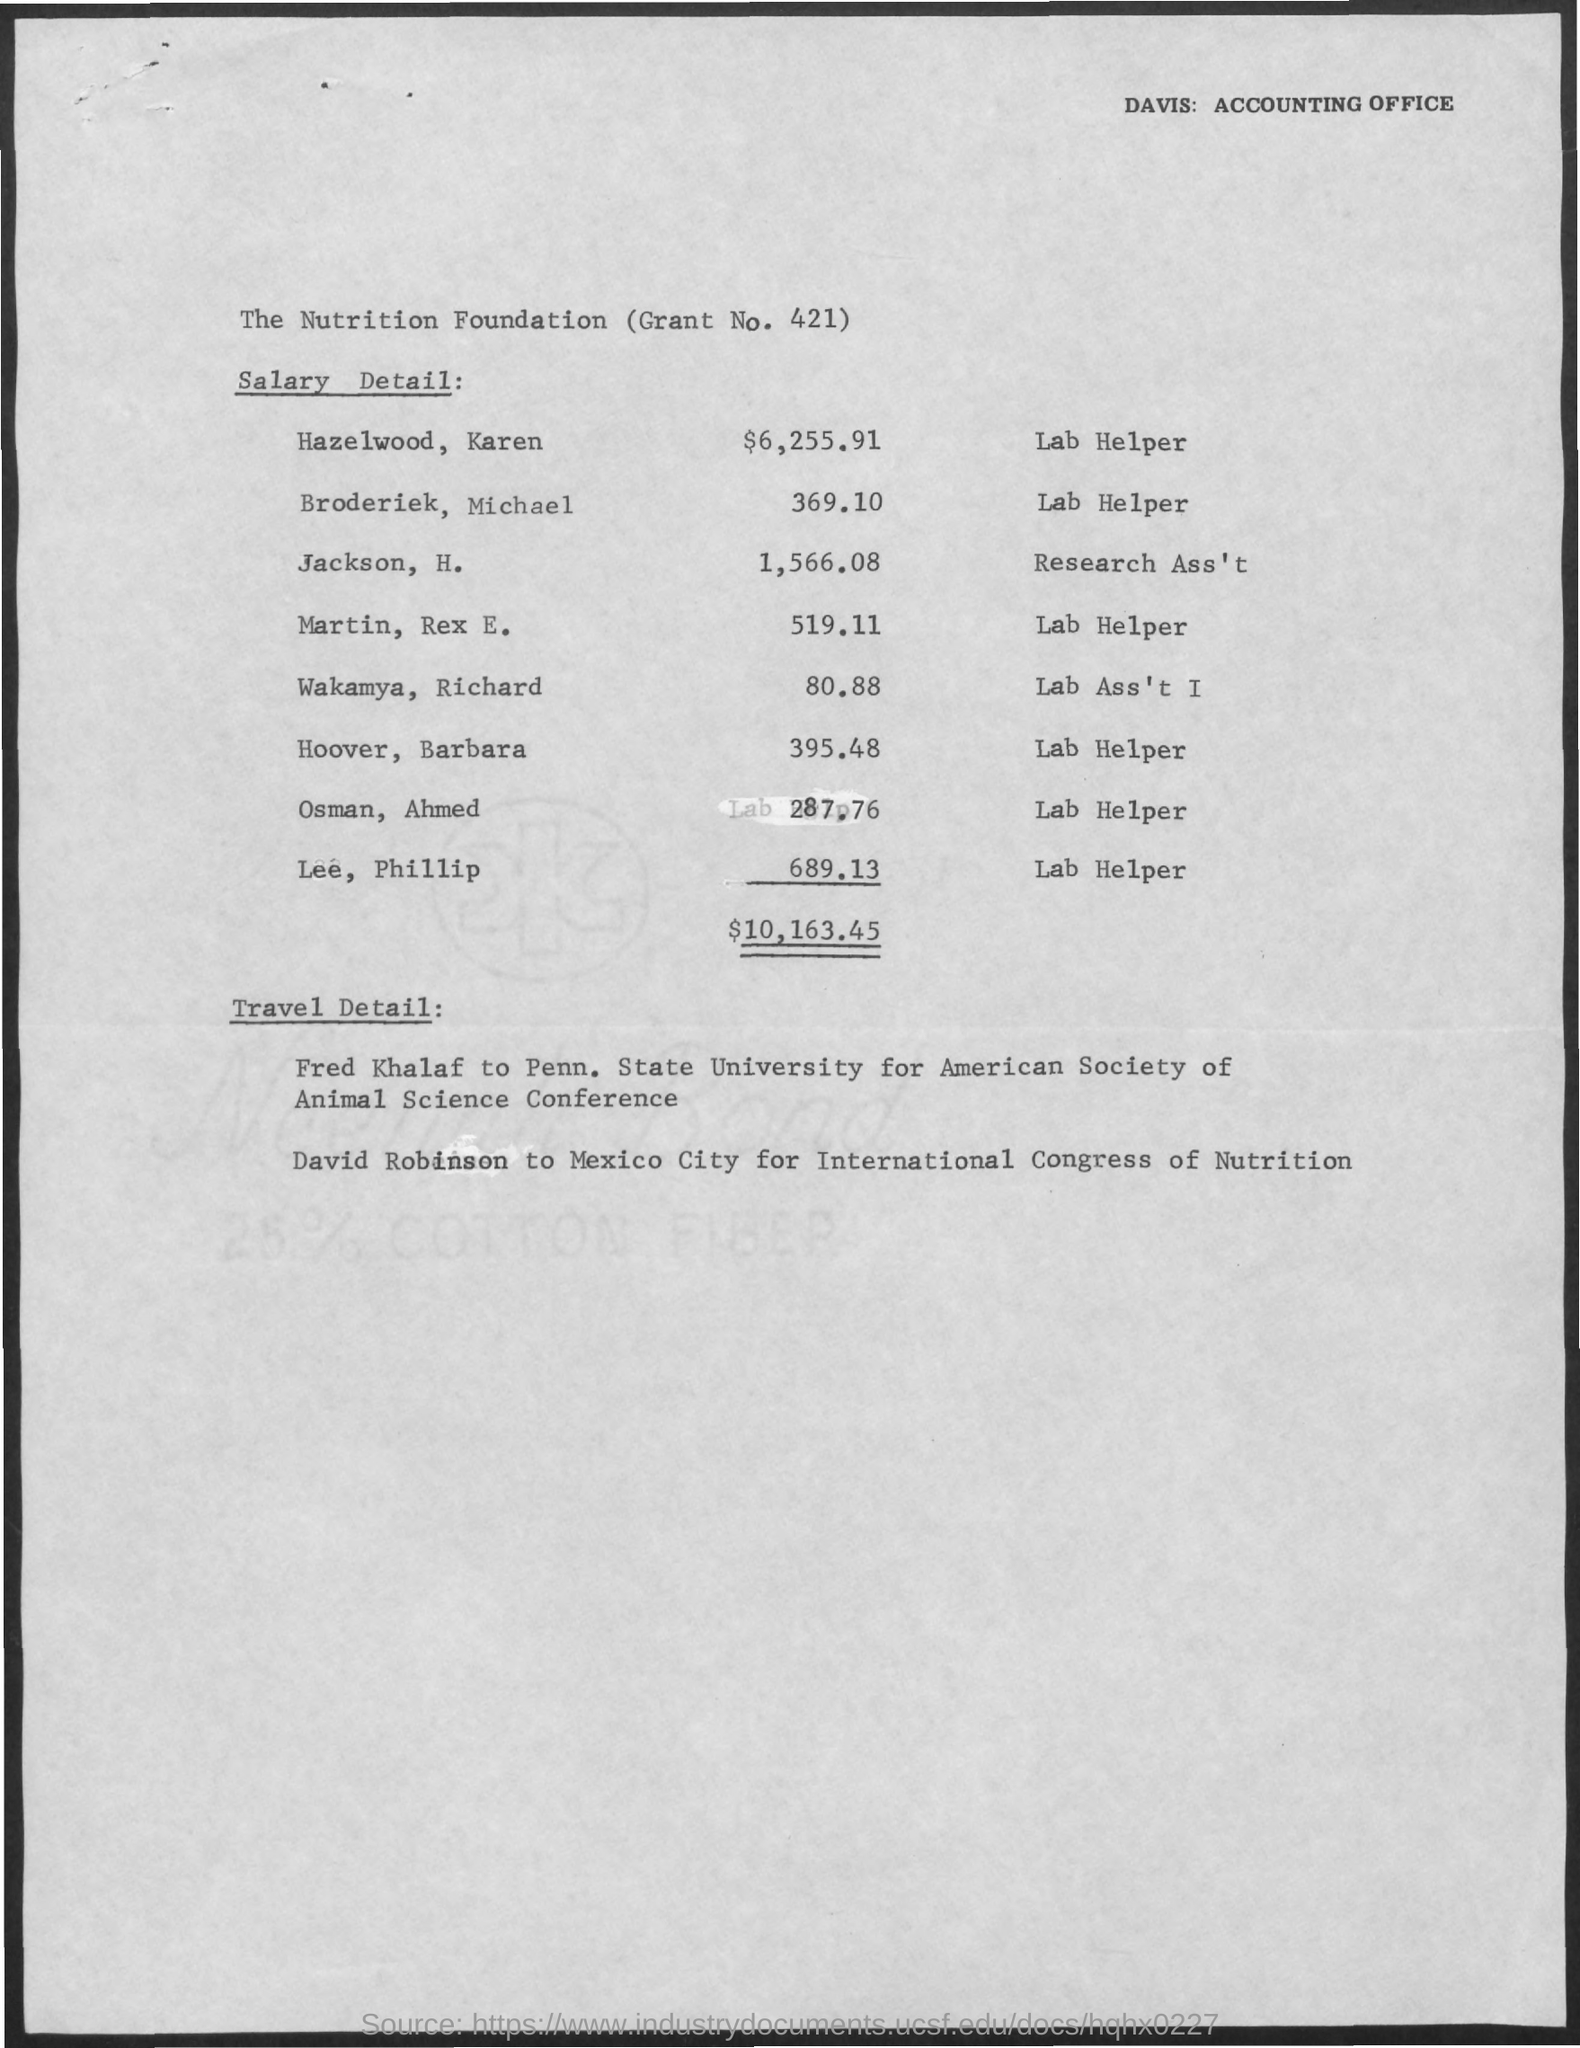Point out several critical features in this image. The salary for Osman Ahmed is 287.76. The salary for Martin, Rex E. is 519.11 dollars. The salary for Wakamya, Richard is 80.88. The salary for Hazelwood, Karen is $6,225.91. The salary for Hoover, Barbara is 395.48. 